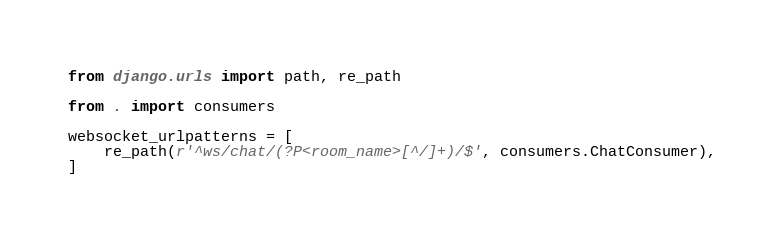<code> <loc_0><loc_0><loc_500><loc_500><_Python_>from django.urls import path, re_path

from . import consumers

websocket_urlpatterns = [
    re_path(r'^ws/chat/(?P<room_name>[^/]+)/$', consumers.ChatConsumer),
]
</code> 